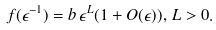Convert formula to latex. <formula><loc_0><loc_0><loc_500><loc_500>f ( \epsilon ^ { - 1 } ) = b \, \epsilon ^ { L } ( 1 + O ( \epsilon ) ) , \, L > 0 .</formula> 